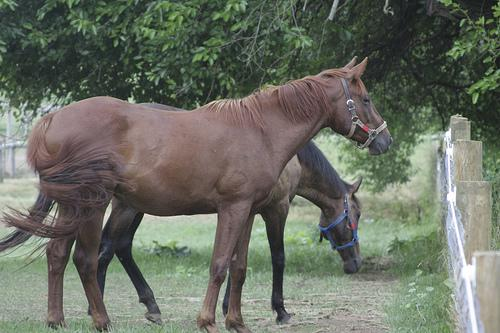Question: where was picture taken?
Choices:
A. In a ZOO.
B. In the city.
C. In Monaco.
D. On a farm or ranch.
Answer with the letter. Answer: D Question: what are horses doing?
Choices:
A. Eating.
B. Running.
C. Sleeping.
D. Walking.
Answer with the letter. Answer: D Question: how many horses are there?
Choices:
A. Two.
B. Five.
C. Four.
D. Six.
Answer with the letter. Answer: A Question: what are horses swinging?
Choices:
A. Heads.
B. Tassels.
C. Tails.
D. Legs.
Answer with the letter. Answer: C 